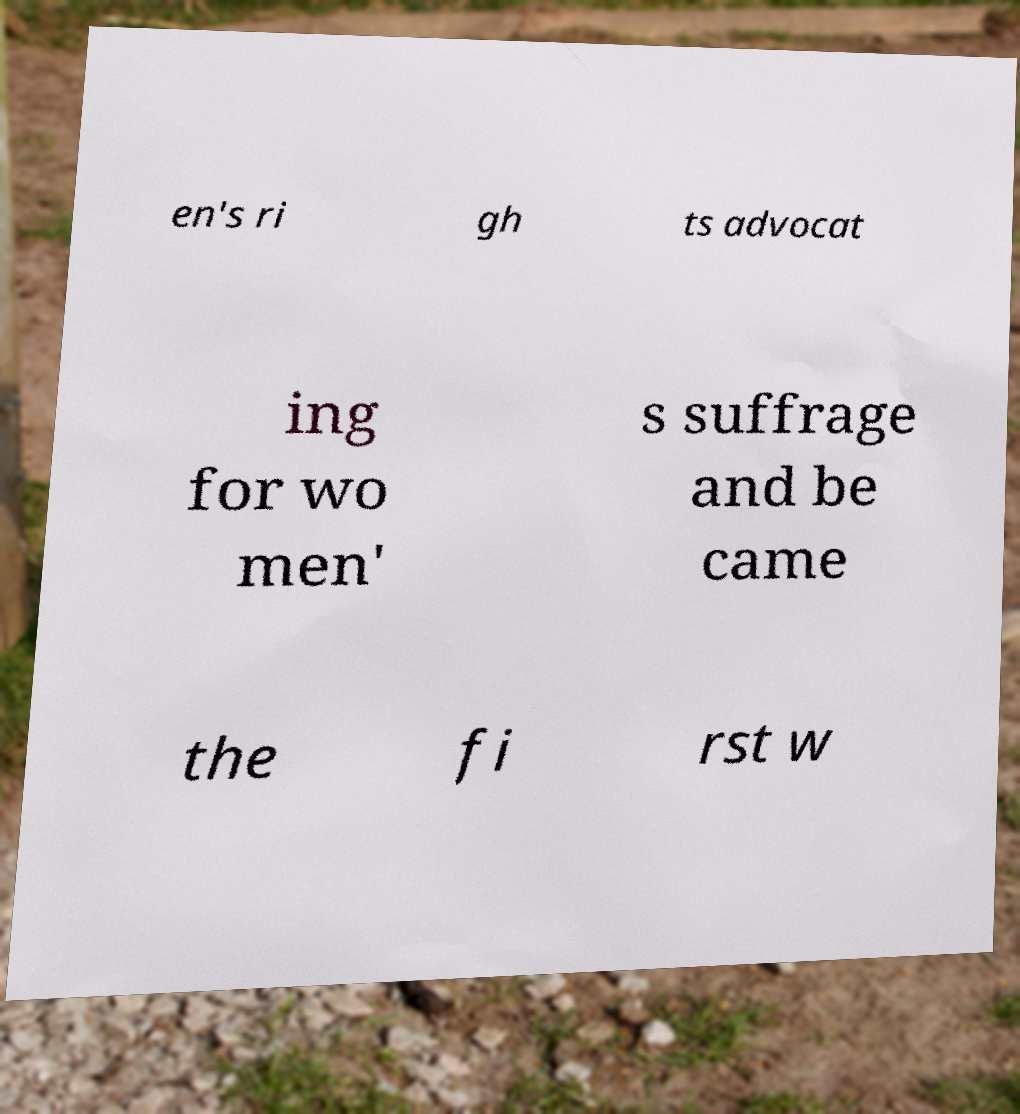What messages or text are displayed in this image? I need them in a readable, typed format. en's ri gh ts advocat ing for wo men' s suffrage and be came the fi rst w 